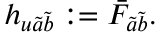Convert formula to latex. <formula><loc_0><loc_0><loc_500><loc_500>h _ { u \tilde { a } \tilde { b } } \colon = \bar { F } _ { \tilde { a } \tilde { b } } .</formula> 